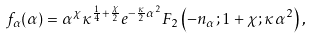<formula> <loc_0><loc_0><loc_500><loc_500>f _ { \alpha } ( \alpha ) = \alpha ^ { \chi } \kappa ^ { \frac { 1 } { 4 } + \frac { \chi } { 2 } } e ^ { - \frac { \kappa } { 2 } \alpha ^ { 2 } } F _ { 2 } \left ( - n _ { \alpha } ; 1 + \chi ; \kappa \alpha ^ { 2 } \right ) ,</formula> 